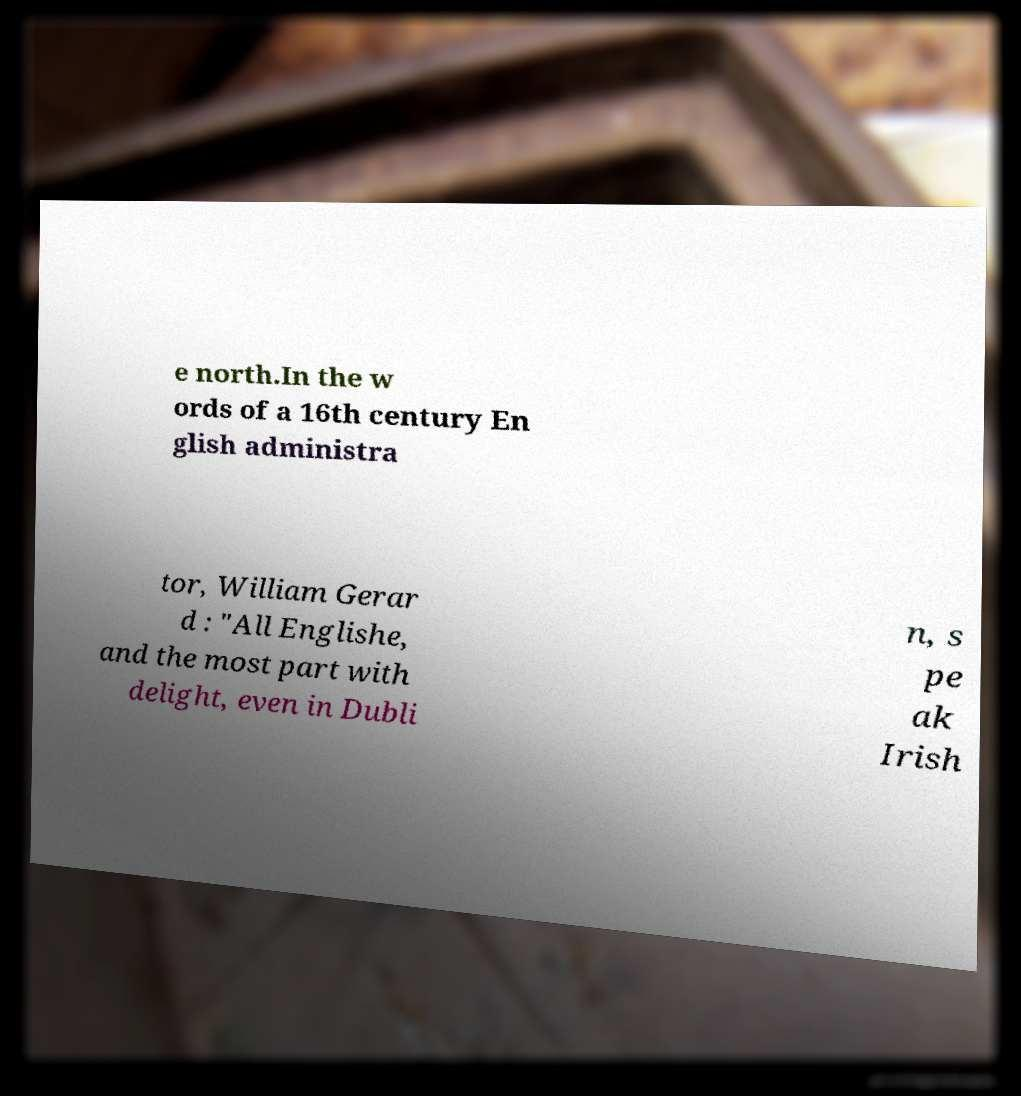Could you assist in decoding the text presented in this image and type it out clearly? e north.In the w ords of a 16th century En glish administra tor, William Gerar d : "All Englishe, and the most part with delight, even in Dubli n, s pe ak Irish 